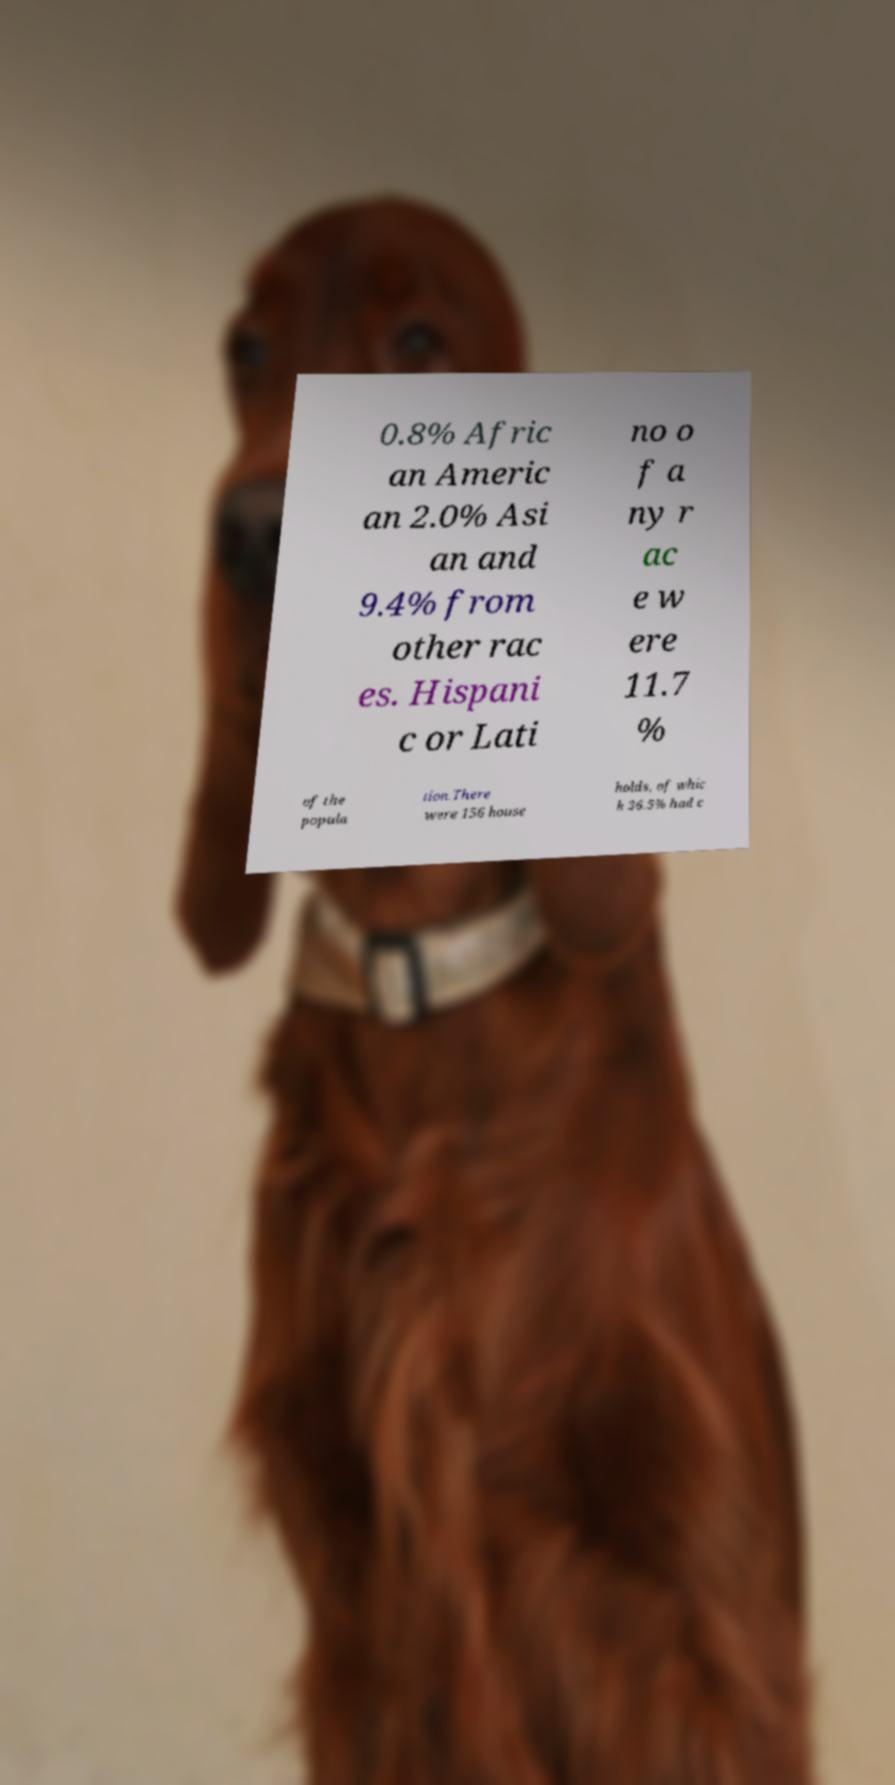Please read and relay the text visible in this image. What does it say? 0.8% Afric an Americ an 2.0% Asi an and 9.4% from other rac es. Hispani c or Lati no o f a ny r ac e w ere 11.7 % of the popula tion.There were 156 house holds, of whic h 36.5% had c 